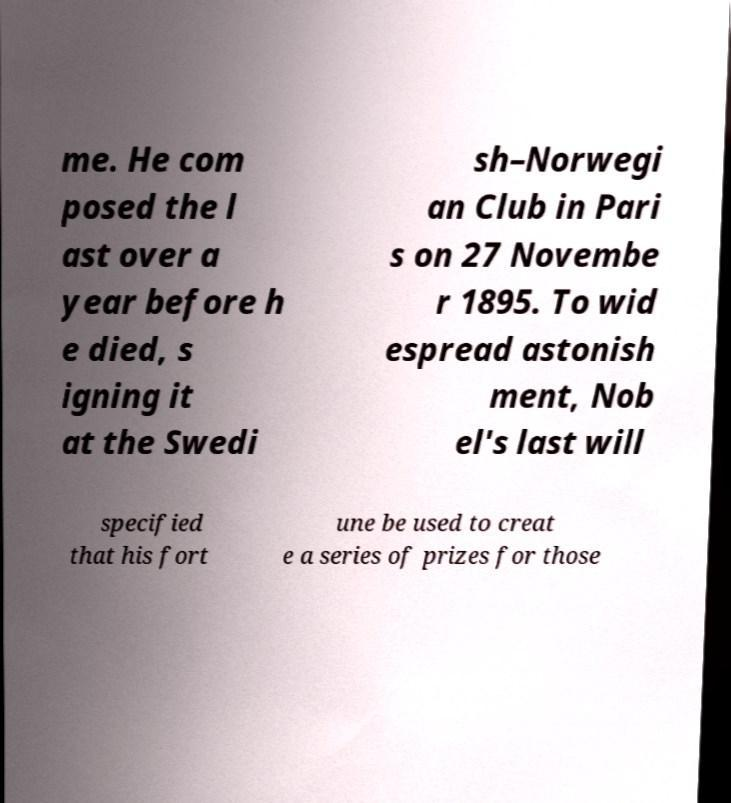Can you read and provide the text displayed in the image?This photo seems to have some interesting text. Can you extract and type it out for me? me. He com posed the l ast over a year before h e died, s igning it at the Swedi sh–Norwegi an Club in Pari s on 27 Novembe r 1895. To wid espread astonish ment, Nob el's last will specified that his fort une be used to creat e a series of prizes for those 